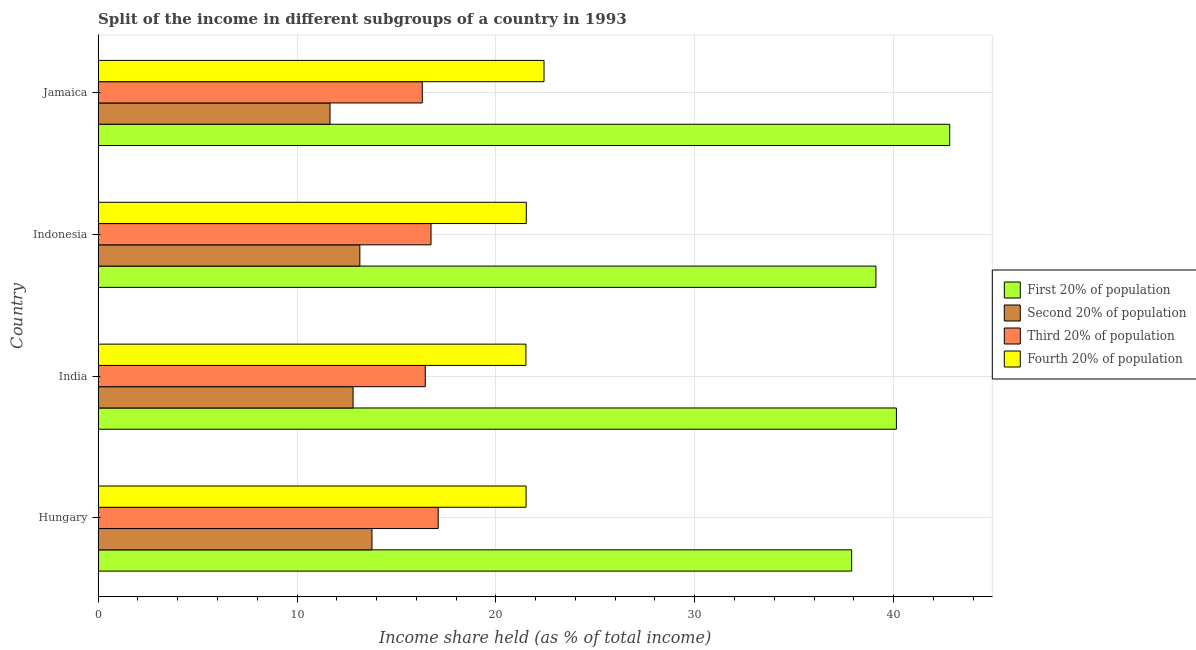How many bars are there on the 3rd tick from the top?
Give a very brief answer. 4. How many bars are there on the 2nd tick from the bottom?
Make the answer very short. 4. What is the share of the income held by first 20% of the population in Jamaica?
Your response must be concise. 42.82. Across all countries, what is the maximum share of the income held by first 20% of the population?
Offer a terse response. 42.82. Across all countries, what is the minimum share of the income held by second 20% of the population?
Offer a very short reply. 11.66. In which country was the share of the income held by third 20% of the population maximum?
Offer a terse response. Hungary. In which country was the share of the income held by third 20% of the population minimum?
Offer a terse response. Jamaica. What is the total share of the income held by fourth 20% of the population in the graph?
Keep it short and to the point. 86.98. What is the difference between the share of the income held by fourth 20% of the population in India and that in Indonesia?
Provide a succinct answer. -0.02. What is the difference between the share of the income held by second 20% of the population in Hungary and the share of the income held by first 20% of the population in Indonesia?
Your answer should be compact. -25.34. What is the average share of the income held by first 20% of the population per country?
Your answer should be compact. 39.99. What is the difference between the share of the income held by third 20% of the population and share of the income held by fourth 20% of the population in Jamaica?
Make the answer very short. -6.12. Is the difference between the share of the income held by third 20% of the population in Hungary and Indonesia greater than the difference between the share of the income held by second 20% of the population in Hungary and Indonesia?
Give a very brief answer. No. What is the difference between the highest and the second highest share of the income held by third 20% of the population?
Ensure brevity in your answer.  0.36. What is the difference between the highest and the lowest share of the income held by first 20% of the population?
Your answer should be very brief. 4.93. What does the 3rd bar from the top in Indonesia represents?
Make the answer very short. Second 20% of population. What does the 2nd bar from the bottom in Jamaica represents?
Your answer should be compact. Second 20% of population. How many bars are there?
Ensure brevity in your answer.  16. Are all the bars in the graph horizontal?
Your response must be concise. Yes. Are the values on the major ticks of X-axis written in scientific E-notation?
Your response must be concise. No. Does the graph contain any zero values?
Provide a short and direct response. No. How are the legend labels stacked?
Your response must be concise. Vertical. What is the title of the graph?
Offer a very short reply. Split of the income in different subgroups of a country in 1993. Does "Greece" appear as one of the legend labels in the graph?
Provide a succinct answer. No. What is the label or title of the X-axis?
Offer a very short reply. Income share held (as % of total income). What is the Income share held (as % of total income) in First 20% of population in Hungary?
Provide a short and direct response. 37.89. What is the Income share held (as % of total income) of Second 20% of population in Hungary?
Your answer should be compact. 13.77. What is the Income share held (as % of total income) in Fourth 20% of population in Hungary?
Make the answer very short. 21.52. What is the Income share held (as % of total income) in First 20% of population in India?
Ensure brevity in your answer.  40.14. What is the Income share held (as % of total income) of Second 20% of population in India?
Offer a terse response. 12.82. What is the Income share held (as % of total income) of Third 20% of population in India?
Your response must be concise. 16.45. What is the Income share held (as % of total income) of Fourth 20% of population in India?
Provide a short and direct response. 21.51. What is the Income share held (as % of total income) of First 20% of population in Indonesia?
Make the answer very short. 39.11. What is the Income share held (as % of total income) of Second 20% of population in Indonesia?
Provide a succinct answer. 13.16. What is the Income share held (as % of total income) in Third 20% of population in Indonesia?
Offer a terse response. 16.74. What is the Income share held (as % of total income) of Fourth 20% of population in Indonesia?
Keep it short and to the point. 21.53. What is the Income share held (as % of total income) of First 20% of population in Jamaica?
Give a very brief answer. 42.82. What is the Income share held (as % of total income) of Second 20% of population in Jamaica?
Provide a succinct answer. 11.66. What is the Income share held (as % of total income) in Third 20% of population in Jamaica?
Provide a succinct answer. 16.3. What is the Income share held (as % of total income) of Fourth 20% of population in Jamaica?
Give a very brief answer. 22.42. Across all countries, what is the maximum Income share held (as % of total income) of First 20% of population?
Your answer should be very brief. 42.82. Across all countries, what is the maximum Income share held (as % of total income) in Second 20% of population?
Your answer should be very brief. 13.77. Across all countries, what is the maximum Income share held (as % of total income) in Third 20% of population?
Give a very brief answer. 17.1. Across all countries, what is the maximum Income share held (as % of total income) of Fourth 20% of population?
Your answer should be very brief. 22.42. Across all countries, what is the minimum Income share held (as % of total income) of First 20% of population?
Provide a short and direct response. 37.89. Across all countries, what is the minimum Income share held (as % of total income) in Second 20% of population?
Your answer should be very brief. 11.66. Across all countries, what is the minimum Income share held (as % of total income) in Third 20% of population?
Give a very brief answer. 16.3. Across all countries, what is the minimum Income share held (as % of total income) of Fourth 20% of population?
Your answer should be compact. 21.51. What is the total Income share held (as % of total income) of First 20% of population in the graph?
Give a very brief answer. 159.96. What is the total Income share held (as % of total income) in Second 20% of population in the graph?
Offer a terse response. 51.41. What is the total Income share held (as % of total income) of Third 20% of population in the graph?
Make the answer very short. 66.59. What is the total Income share held (as % of total income) in Fourth 20% of population in the graph?
Your response must be concise. 86.98. What is the difference between the Income share held (as % of total income) in First 20% of population in Hungary and that in India?
Your answer should be very brief. -2.25. What is the difference between the Income share held (as % of total income) in Second 20% of population in Hungary and that in India?
Give a very brief answer. 0.95. What is the difference between the Income share held (as % of total income) in Third 20% of population in Hungary and that in India?
Offer a terse response. 0.65. What is the difference between the Income share held (as % of total income) of Fourth 20% of population in Hungary and that in India?
Make the answer very short. 0.01. What is the difference between the Income share held (as % of total income) of First 20% of population in Hungary and that in Indonesia?
Ensure brevity in your answer.  -1.22. What is the difference between the Income share held (as % of total income) of Second 20% of population in Hungary and that in Indonesia?
Your answer should be very brief. 0.61. What is the difference between the Income share held (as % of total income) of Third 20% of population in Hungary and that in Indonesia?
Your answer should be compact. 0.36. What is the difference between the Income share held (as % of total income) of Fourth 20% of population in Hungary and that in Indonesia?
Keep it short and to the point. -0.01. What is the difference between the Income share held (as % of total income) of First 20% of population in Hungary and that in Jamaica?
Provide a short and direct response. -4.93. What is the difference between the Income share held (as % of total income) of Second 20% of population in Hungary and that in Jamaica?
Ensure brevity in your answer.  2.11. What is the difference between the Income share held (as % of total income) of Third 20% of population in Hungary and that in Jamaica?
Your answer should be very brief. 0.8. What is the difference between the Income share held (as % of total income) of Fourth 20% of population in Hungary and that in Jamaica?
Give a very brief answer. -0.9. What is the difference between the Income share held (as % of total income) in Second 20% of population in India and that in Indonesia?
Give a very brief answer. -0.34. What is the difference between the Income share held (as % of total income) of Third 20% of population in India and that in Indonesia?
Your answer should be compact. -0.29. What is the difference between the Income share held (as % of total income) in Fourth 20% of population in India and that in Indonesia?
Your answer should be very brief. -0.02. What is the difference between the Income share held (as % of total income) of First 20% of population in India and that in Jamaica?
Provide a short and direct response. -2.68. What is the difference between the Income share held (as % of total income) in Second 20% of population in India and that in Jamaica?
Ensure brevity in your answer.  1.16. What is the difference between the Income share held (as % of total income) of Third 20% of population in India and that in Jamaica?
Make the answer very short. 0.15. What is the difference between the Income share held (as % of total income) in Fourth 20% of population in India and that in Jamaica?
Your answer should be very brief. -0.91. What is the difference between the Income share held (as % of total income) of First 20% of population in Indonesia and that in Jamaica?
Ensure brevity in your answer.  -3.71. What is the difference between the Income share held (as % of total income) of Third 20% of population in Indonesia and that in Jamaica?
Keep it short and to the point. 0.44. What is the difference between the Income share held (as % of total income) in Fourth 20% of population in Indonesia and that in Jamaica?
Make the answer very short. -0.89. What is the difference between the Income share held (as % of total income) of First 20% of population in Hungary and the Income share held (as % of total income) of Second 20% of population in India?
Offer a terse response. 25.07. What is the difference between the Income share held (as % of total income) of First 20% of population in Hungary and the Income share held (as % of total income) of Third 20% of population in India?
Your answer should be very brief. 21.44. What is the difference between the Income share held (as % of total income) in First 20% of population in Hungary and the Income share held (as % of total income) in Fourth 20% of population in India?
Your answer should be compact. 16.38. What is the difference between the Income share held (as % of total income) in Second 20% of population in Hungary and the Income share held (as % of total income) in Third 20% of population in India?
Your answer should be compact. -2.68. What is the difference between the Income share held (as % of total income) in Second 20% of population in Hungary and the Income share held (as % of total income) in Fourth 20% of population in India?
Provide a short and direct response. -7.74. What is the difference between the Income share held (as % of total income) in Third 20% of population in Hungary and the Income share held (as % of total income) in Fourth 20% of population in India?
Give a very brief answer. -4.41. What is the difference between the Income share held (as % of total income) in First 20% of population in Hungary and the Income share held (as % of total income) in Second 20% of population in Indonesia?
Your response must be concise. 24.73. What is the difference between the Income share held (as % of total income) in First 20% of population in Hungary and the Income share held (as % of total income) in Third 20% of population in Indonesia?
Ensure brevity in your answer.  21.15. What is the difference between the Income share held (as % of total income) in First 20% of population in Hungary and the Income share held (as % of total income) in Fourth 20% of population in Indonesia?
Make the answer very short. 16.36. What is the difference between the Income share held (as % of total income) in Second 20% of population in Hungary and the Income share held (as % of total income) in Third 20% of population in Indonesia?
Provide a short and direct response. -2.97. What is the difference between the Income share held (as % of total income) of Second 20% of population in Hungary and the Income share held (as % of total income) of Fourth 20% of population in Indonesia?
Give a very brief answer. -7.76. What is the difference between the Income share held (as % of total income) of Third 20% of population in Hungary and the Income share held (as % of total income) of Fourth 20% of population in Indonesia?
Ensure brevity in your answer.  -4.43. What is the difference between the Income share held (as % of total income) of First 20% of population in Hungary and the Income share held (as % of total income) of Second 20% of population in Jamaica?
Offer a very short reply. 26.23. What is the difference between the Income share held (as % of total income) in First 20% of population in Hungary and the Income share held (as % of total income) in Third 20% of population in Jamaica?
Your answer should be compact. 21.59. What is the difference between the Income share held (as % of total income) of First 20% of population in Hungary and the Income share held (as % of total income) of Fourth 20% of population in Jamaica?
Provide a succinct answer. 15.47. What is the difference between the Income share held (as % of total income) in Second 20% of population in Hungary and the Income share held (as % of total income) in Third 20% of population in Jamaica?
Provide a succinct answer. -2.53. What is the difference between the Income share held (as % of total income) of Second 20% of population in Hungary and the Income share held (as % of total income) of Fourth 20% of population in Jamaica?
Ensure brevity in your answer.  -8.65. What is the difference between the Income share held (as % of total income) in Third 20% of population in Hungary and the Income share held (as % of total income) in Fourth 20% of population in Jamaica?
Ensure brevity in your answer.  -5.32. What is the difference between the Income share held (as % of total income) of First 20% of population in India and the Income share held (as % of total income) of Second 20% of population in Indonesia?
Offer a very short reply. 26.98. What is the difference between the Income share held (as % of total income) in First 20% of population in India and the Income share held (as % of total income) in Third 20% of population in Indonesia?
Offer a very short reply. 23.4. What is the difference between the Income share held (as % of total income) of First 20% of population in India and the Income share held (as % of total income) of Fourth 20% of population in Indonesia?
Provide a succinct answer. 18.61. What is the difference between the Income share held (as % of total income) in Second 20% of population in India and the Income share held (as % of total income) in Third 20% of population in Indonesia?
Provide a short and direct response. -3.92. What is the difference between the Income share held (as % of total income) in Second 20% of population in India and the Income share held (as % of total income) in Fourth 20% of population in Indonesia?
Provide a succinct answer. -8.71. What is the difference between the Income share held (as % of total income) in Third 20% of population in India and the Income share held (as % of total income) in Fourth 20% of population in Indonesia?
Make the answer very short. -5.08. What is the difference between the Income share held (as % of total income) in First 20% of population in India and the Income share held (as % of total income) in Second 20% of population in Jamaica?
Ensure brevity in your answer.  28.48. What is the difference between the Income share held (as % of total income) of First 20% of population in India and the Income share held (as % of total income) of Third 20% of population in Jamaica?
Make the answer very short. 23.84. What is the difference between the Income share held (as % of total income) of First 20% of population in India and the Income share held (as % of total income) of Fourth 20% of population in Jamaica?
Keep it short and to the point. 17.72. What is the difference between the Income share held (as % of total income) of Second 20% of population in India and the Income share held (as % of total income) of Third 20% of population in Jamaica?
Make the answer very short. -3.48. What is the difference between the Income share held (as % of total income) in Second 20% of population in India and the Income share held (as % of total income) in Fourth 20% of population in Jamaica?
Keep it short and to the point. -9.6. What is the difference between the Income share held (as % of total income) in Third 20% of population in India and the Income share held (as % of total income) in Fourth 20% of population in Jamaica?
Your response must be concise. -5.97. What is the difference between the Income share held (as % of total income) of First 20% of population in Indonesia and the Income share held (as % of total income) of Second 20% of population in Jamaica?
Your answer should be compact. 27.45. What is the difference between the Income share held (as % of total income) in First 20% of population in Indonesia and the Income share held (as % of total income) in Third 20% of population in Jamaica?
Ensure brevity in your answer.  22.81. What is the difference between the Income share held (as % of total income) in First 20% of population in Indonesia and the Income share held (as % of total income) in Fourth 20% of population in Jamaica?
Your answer should be very brief. 16.69. What is the difference between the Income share held (as % of total income) of Second 20% of population in Indonesia and the Income share held (as % of total income) of Third 20% of population in Jamaica?
Make the answer very short. -3.14. What is the difference between the Income share held (as % of total income) in Second 20% of population in Indonesia and the Income share held (as % of total income) in Fourth 20% of population in Jamaica?
Make the answer very short. -9.26. What is the difference between the Income share held (as % of total income) in Third 20% of population in Indonesia and the Income share held (as % of total income) in Fourth 20% of population in Jamaica?
Offer a very short reply. -5.68. What is the average Income share held (as % of total income) in First 20% of population per country?
Your response must be concise. 39.99. What is the average Income share held (as % of total income) in Second 20% of population per country?
Keep it short and to the point. 12.85. What is the average Income share held (as % of total income) in Third 20% of population per country?
Make the answer very short. 16.65. What is the average Income share held (as % of total income) in Fourth 20% of population per country?
Offer a very short reply. 21.75. What is the difference between the Income share held (as % of total income) in First 20% of population and Income share held (as % of total income) in Second 20% of population in Hungary?
Ensure brevity in your answer.  24.12. What is the difference between the Income share held (as % of total income) in First 20% of population and Income share held (as % of total income) in Third 20% of population in Hungary?
Your answer should be very brief. 20.79. What is the difference between the Income share held (as % of total income) in First 20% of population and Income share held (as % of total income) in Fourth 20% of population in Hungary?
Provide a succinct answer. 16.37. What is the difference between the Income share held (as % of total income) of Second 20% of population and Income share held (as % of total income) of Third 20% of population in Hungary?
Your response must be concise. -3.33. What is the difference between the Income share held (as % of total income) of Second 20% of population and Income share held (as % of total income) of Fourth 20% of population in Hungary?
Your response must be concise. -7.75. What is the difference between the Income share held (as % of total income) of Third 20% of population and Income share held (as % of total income) of Fourth 20% of population in Hungary?
Your answer should be very brief. -4.42. What is the difference between the Income share held (as % of total income) of First 20% of population and Income share held (as % of total income) of Second 20% of population in India?
Your answer should be very brief. 27.32. What is the difference between the Income share held (as % of total income) of First 20% of population and Income share held (as % of total income) of Third 20% of population in India?
Give a very brief answer. 23.69. What is the difference between the Income share held (as % of total income) of First 20% of population and Income share held (as % of total income) of Fourth 20% of population in India?
Offer a terse response. 18.63. What is the difference between the Income share held (as % of total income) in Second 20% of population and Income share held (as % of total income) in Third 20% of population in India?
Ensure brevity in your answer.  -3.63. What is the difference between the Income share held (as % of total income) of Second 20% of population and Income share held (as % of total income) of Fourth 20% of population in India?
Your answer should be very brief. -8.69. What is the difference between the Income share held (as % of total income) of Third 20% of population and Income share held (as % of total income) of Fourth 20% of population in India?
Your answer should be very brief. -5.06. What is the difference between the Income share held (as % of total income) of First 20% of population and Income share held (as % of total income) of Second 20% of population in Indonesia?
Give a very brief answer. 25.95. What is the difference between the Income share held (as % of total income) of First 20% of population and Income share held (as % of total income) of Third 20% of population in Indonesia?
Ensure brevity in your answer.  22.37. What is the difference between the Income share held (as % of total income) of First 20% of population and Income share held (as % of total income) of Fourth 20% of population in Indonesia?
Provide a succinct answer. 17.58. What is the difference between the Income share held (as % of total income) in Second 20% of population and Income share held (as % of total income) in Third 20% of population in Indonesia?
Offer a very short reply. -3.58. What is the difference between the Income share held (as % of total income) in Second 20% of population and Income share held (as % of total income) in Fourth 20% of population in Indonesia?
Provide a short and direct response. -8.37. What is the difference between the Income share held (as % of total income) in Third 20% of population and Income share held (as % of total income) in Fourth 20% of population in Indonesia?
Make the answer very short. -4.79. What is the difference between the Income share held (as % of total income) of First 20% of population and Income share held (as % of total income) of Second 20% of population in Jamaica?
Your answer should be compact. 31.16. What is the difference between the Income share held (as % of total income) of First 20% of population and Income share held (as % of total income) of Third 20% of population in Jamaica?
Ensure brevity in your answer.  26.52. What is the difference between the Income share held (as % of total income) in First 20% of population and Income share held (as % of total income) in Fourth 20% of population in Jamaica?
Offer a terse response. 20.4. What is the difference between the Income share held (as % of total income) of Second 20% of population and Income share held (as % of total income) of Third 20% of population in Jamaica?
Offer a very short reply. -4.64. What is the difference between the Income share held (as % of total income) in Second 20% of population and Income share held (as % of total income) in Fourth 20% of population in Jamaica?
Your answer should be compact. -10.76. What is the difference between the Income share held (as % of total income) in Third 20% of population and Income share held (as % of total income) in Fourth 20% of population in Jamaica?
Give a very brief answer. -6.12. What is the ratio of the Income share held (as % of total income) of First 20% of population in Hungary to that in India?
Keep it short and to the point. 0.94. What is the ratio of the Income share held (as % of total income) in Second 20% of population in Hungary to that in India?
Provide a succinct answer. 1.07. What is the ratio of the Income share held (as % of total income) of Third 20% of population in Hungary to that in India?
Provide a succinct answer. 1.04. What is the ratio of the Income share held (as % of total income) in First 20% of population in Hungary to that in Indonesia?
Offer a terse response. 0.97. What is the ratio of the Income share held (as % of total income) in Second 20% of population in Hungary to that in Indonesia?
Your response must be concise. 1.05. What is the ratio of the Income share held (as % of total income) in Third 20% of population in Hungary to that in Indonesia?
Make the answer very short. 1.02. What is the ratio of the Income share held (as % of total income) in First 20% of population in Hungary to that in Jamaica?
Offer a very short reply. 0.88. What is the ratio of the Income share held (as % of total income) of Second 20% of population in Hungary to that in Jamaica?
Provide a succinct answer. 1.18. What is the ratio of the Income share held (as % of total income) of Third 20% of population in Hungary to that in Jamaica?
Offer a terse response. 1.05. What is the ratio of the Income share held (as % of total income) in Fourth 20% of population in Hungary to that in Jamaica?
Provide a succinct answer. 0.96. What is the ratio of the Income share held (as % of total income) in First 20% of population in India to that in Indonesia?
Ensure brevity in your answer.  1.03. What is the ratio of the Income share held (as % of total income) of Second 20% of population in India to that in Indonesia?
Keep it short and to the point. 0.97. What is the ratio of the Income share held (as % of total income) in Third 20% of population in India to that in Indonesia?
Keep it short and to the point. 0.98. What is the ratio of the Income share held (as % of total income) in Fourth 20% of population in India to that in Indonesia?
Offer a terse response. 1. What is the ratio of the Income share held (as % of total income) in First 20% of population in India to that in Jamaica?
Offer a terse response. 0.94. What is the ratio of the Income share held (as % of total income) in Second 20% of population in India to that in Jamaica?
Your answer should be very brief. 1.1. What is the ratio of the Income share held (as % of total income) in Third 20% of population in India to that in Jamaica?
Give a very brief answer. 1.01. What is the ratio of the Income share held (as % of total income) in Fourth 20% of population in India to that in Jamaica?
Offer a terse response. 0.96. What is the ratio of the Income share held (as % of total income) in First 20% of population in Indonesia to that in Jamaica?
Provide a short and direct response. 0.91. What is the ratio of the Income share held (as % of total income) in Second 20% of population in Indonesia to that in Jamaica?
Your answer should be compact. 1.13. What is the ratio of the Income share held (as % of total income) in Fourth 20% of population in Indonesia to that in Jamaica?
Keep it short and to the point. 0.96. What is the difference between the highest and the second highest Income share held (as % of total income) in First 20% of population?
Provide a short and direct response. 2.68. What is the difference between the highest and the second highest Income share held (as % of total income) of Second 20% of population?
Make the answer very short. 0.61. What is the difference between the highest and the second highest Income share held (as % of total income) in Third 20% of population?
Offer a terse response. 0.36. What is the difference between the highest and the second highest Income share held (as % of total income) in Fourth 20% of population?
Make the answer very short. 0.89. What is the difference between the highest and the lowest Income share held (as % of total income) in First 20% of population?
Make the answer very short. 4.93. What is the difference between the highest and the lowest Income share held (as % of total income) in Second 20% of population?
Your response must be concise. 2.11. What is the difference between the highest and the lowest Income share held (as % of total income) of Third 20% of population?
Your response must be concise. 0.8. What is the difference between the highest and the lowest Income share held (as % of total income) in Fourth 20% of population?
Give a very brief answer. 0.91. 